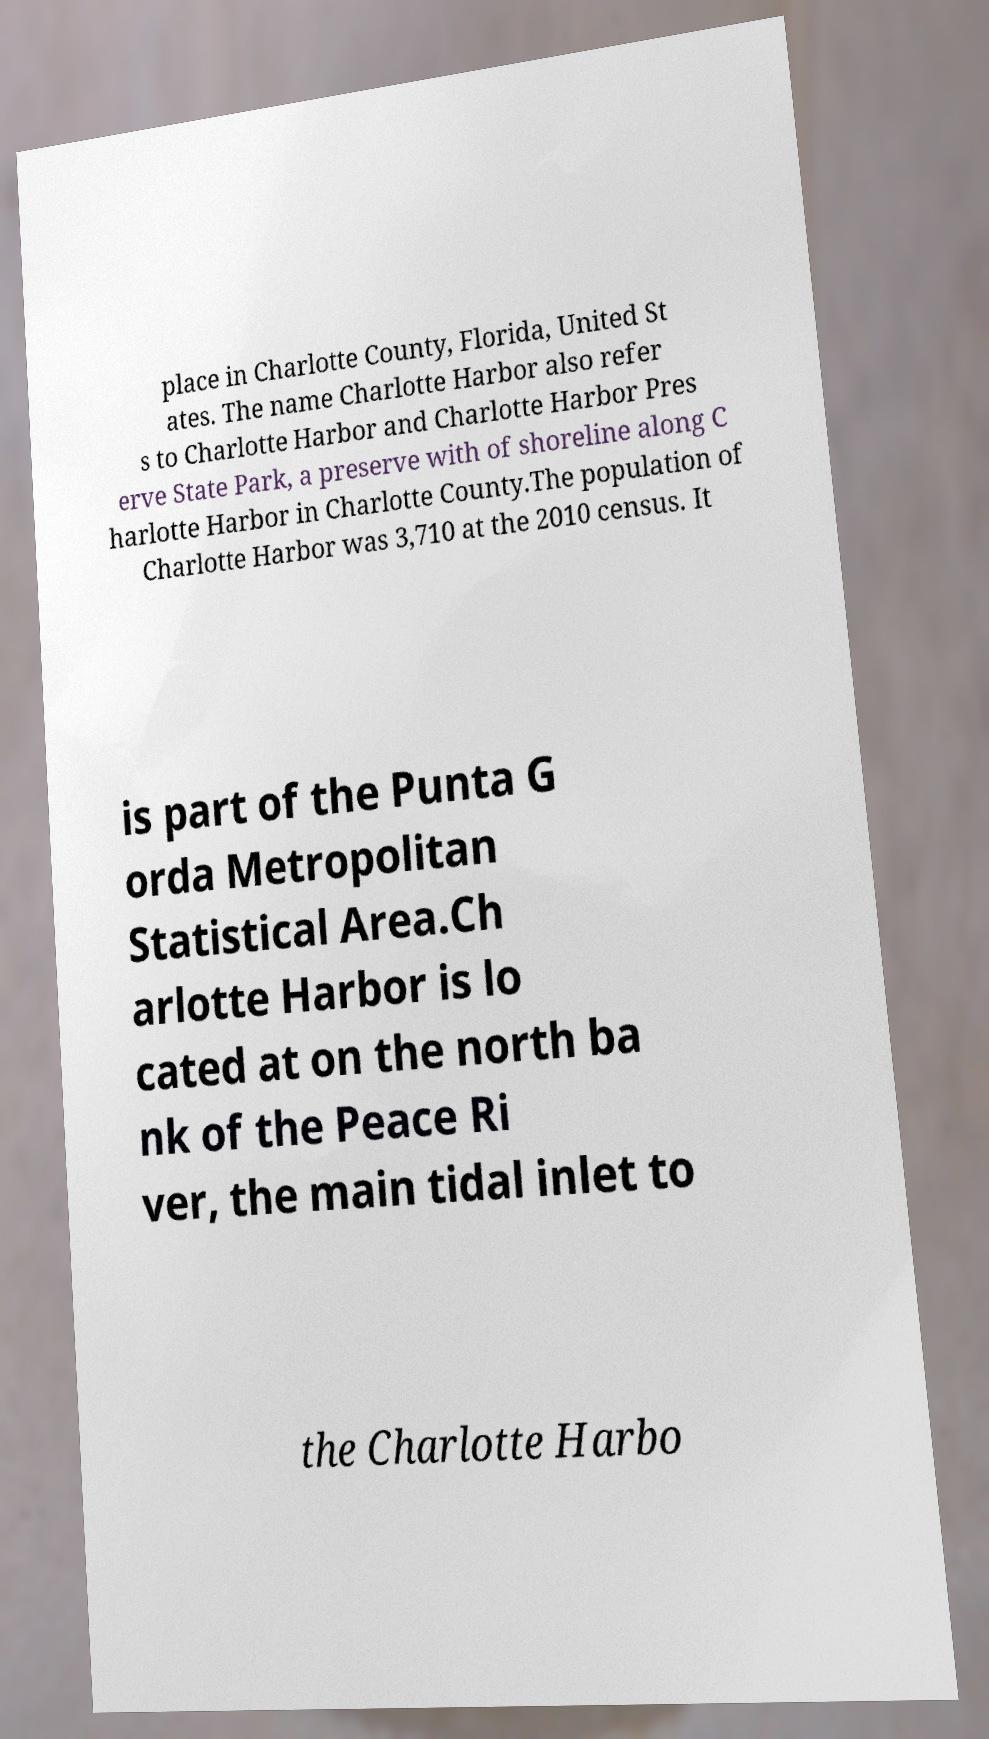What messages or text are displayed in this image? I need them in a readable, typed format. place in Charlotte County, Florida, United St ates. The name Charlotte Harbor also refer s to Charlotte Harbor and Charlotte Harbor Pres erve State Park, a preserve with of shoreline along C harlotte Harbor in Charlotte County.The population of Charlotte Harbor was 3,710 at the 2010 census. It is part of the Punta G orda Metropolitan Statistical Area.Ch arlotte Harbor is lo cated at on the north ba nk of the Peace Ri ver, the main tidal inlet to the Charlotte Harbo 